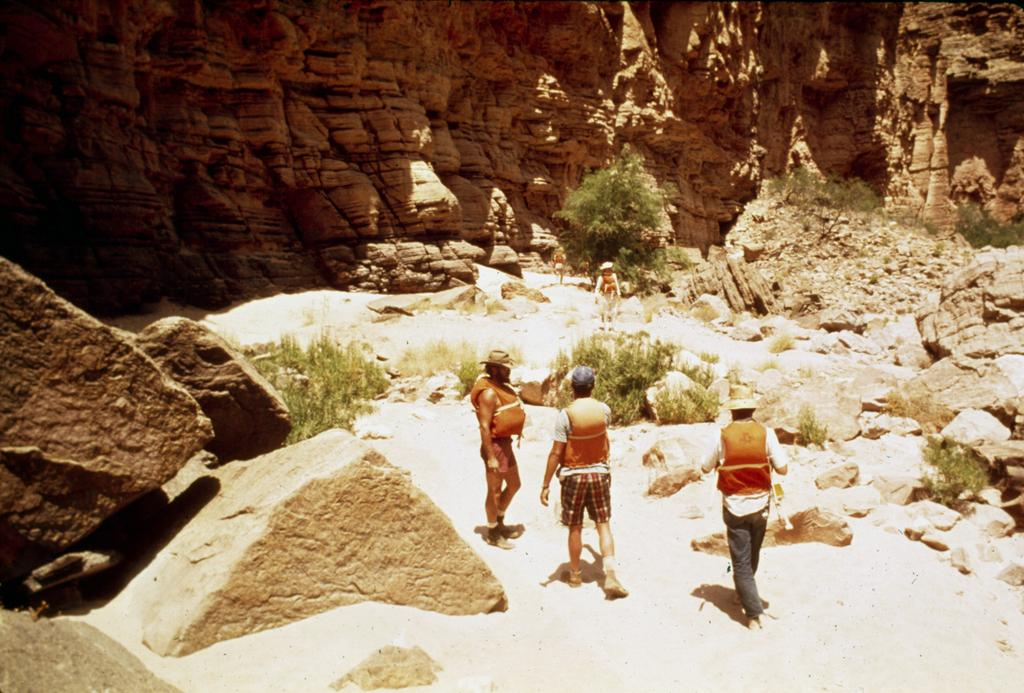How many people are in the image? There are three people in the image. What are the people wearing on their heads? The people are wearing caps. What type of clothing are the people wearing on their upper bodies? The people are wearing jackets. What type of natural elements can be seen in the image? There are rocks and plants in the image. What kind of man-made structure is visible in the background? There is a rock wall in the background of the image. What type of cracker is being used to break the stone in the image? There is no cracker or stone present in the image. Can you tell me how many sinks are visible in the image? There are no sinks visible in the image. 